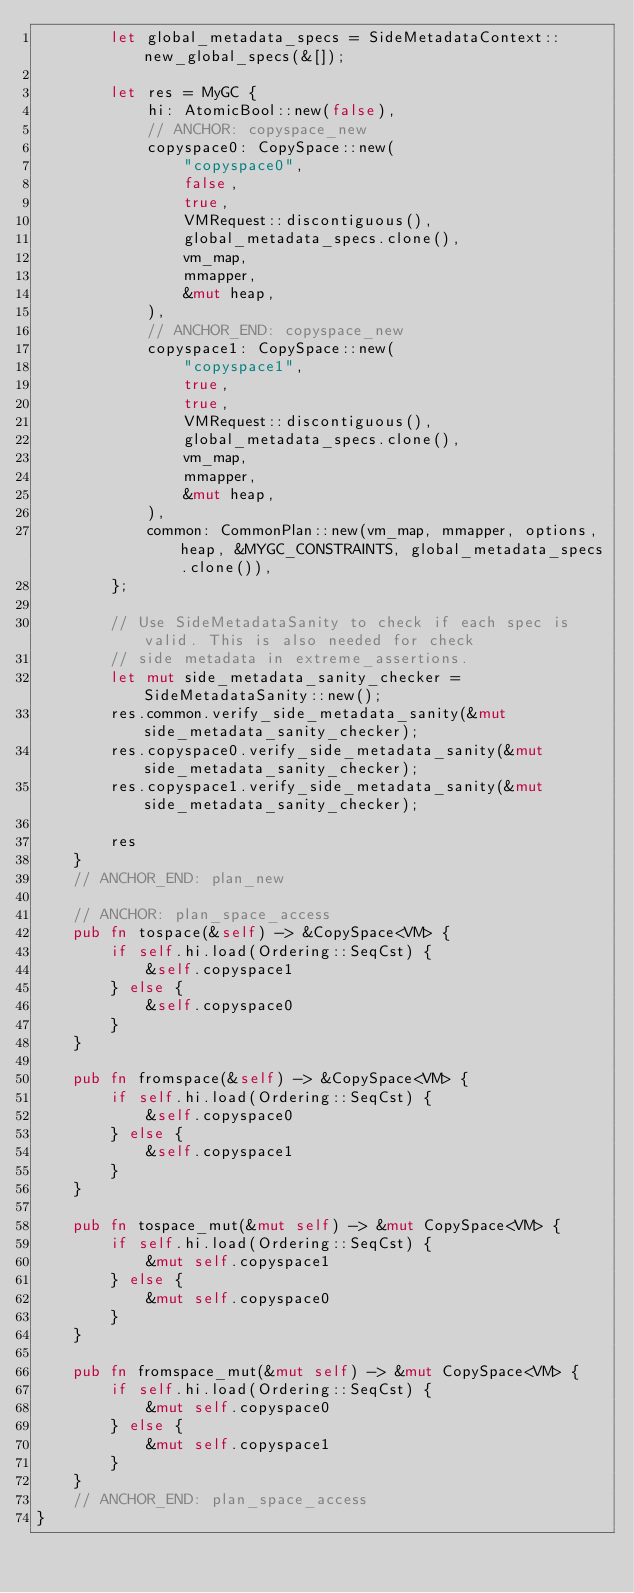Convert code to text. <code><loc_0><loc_0><loc_500><loc_500><_Rust_>        let global_metadata_specs = SideMetadataContext::new_global_specs(&[]);

        let res = MyGC {
            hi: AtomicBool::new(false),
            // ANCHOR: copyspace_new
            copyspace0: CopySpace::new(
                "copyspace0",
                false,
                true,
                VMRequest::discontiguous(),
                global_metadata_specs.clone(),
                vm_map,
                mmapper,
                &mut heap,
            ),
            // ANCHOR_END: copyspace_new
            copyspace1: CopySpace::new(
                "copyspace1",
                true,
                true,
                VMRequest::discontiguous(),
                global_metadata_specs.clone(),
                vm_map,
                mmapper,
                &mut heap,
            ),
            common: CommonPlan::new(vm_map, mmapper, options, heap, &MYGC_CONSTRAINTS, global_metadata_specs.clone()),
        };

        // Use SideMetadataSanity to check if each spec is valid. This is also needed for check
        // side metadata in extreme_assertions.
        let mut side_metadata_sanity_checker = SideMetadataSanity::new();
        res.common.verify_side_metadata_sanity(&mut side_metadata_sanity_checker);
        res.copyspace0.verify_side_metadata_sanity(&mut side_metadata_sanity_checker);
        res.copyspace1.verify_side_metadata_sanity(&mut side_metadata_sanity_checker);

        res
    }
    // ANCHOR_END: plan_new

    // ANCHOR: plan_space_access
    pub fn tospace(&self) -> &CopySpace<VM> {
        if self.hi.load(Ordering::SeqCst) {
            &self.copyspace1
        } else {
            &self.copyspace0
        }
    }

    pub fn fromspace(&self) -> &CopySpace<VM> {
        if self.hi.load(Ordering::SeqCst) {
            &self.copyspace0
        } else {
            &self.copyspace1
        }
    }

    pub fn tospace_mut(&mut self) -> &mut CopySpace<VM> {
        if self.hi.load(Ordering::SeqCst) {
            &mut self.copyspace1
        } else {
            &mut self.copyspace0
        }
    }

    pub fn fromspace_mut(&mut self) -> &mut CopySpace<VM> {
        if self.hi.load(Ordering::SeqCst) {
            &mut self.copyspace0
        } else {
            &mut self.copyspace1
        }
    }
    // ANCHOR_END: plan_space_access
}
</code> 